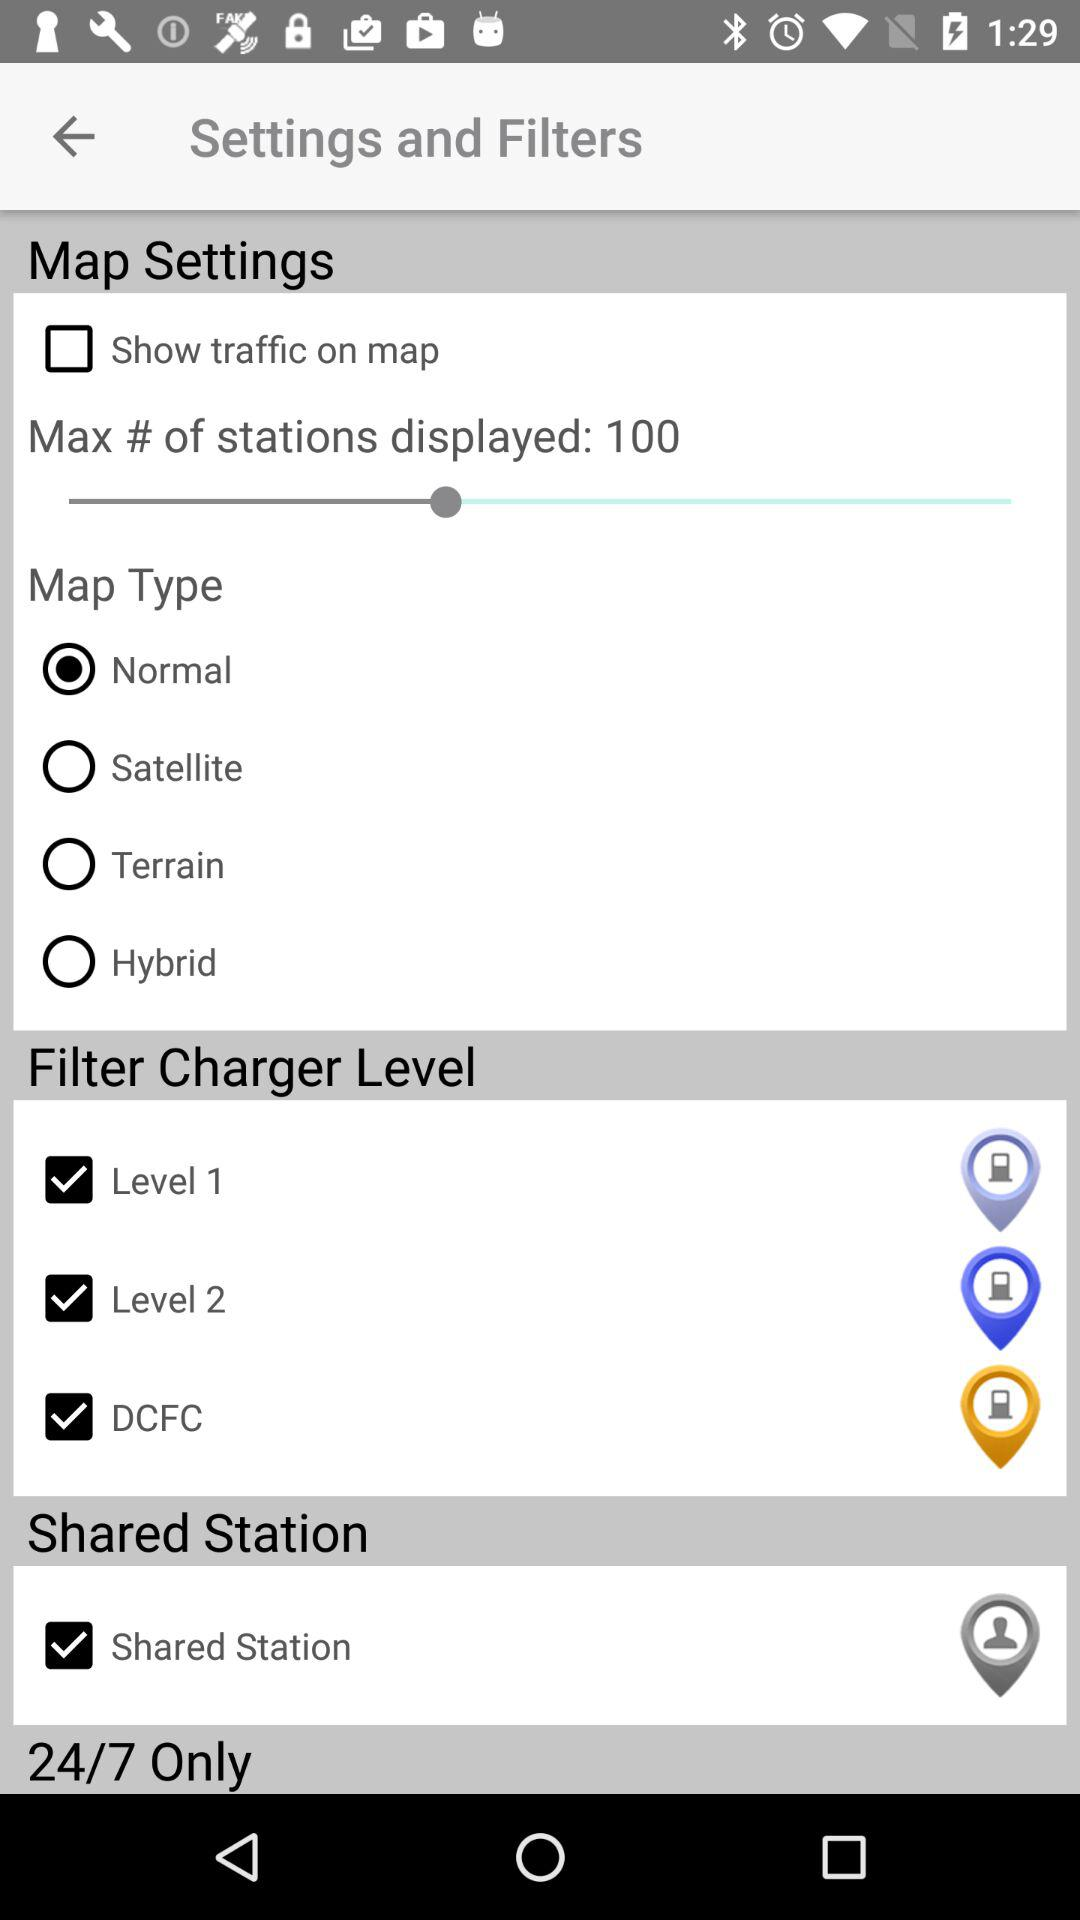What is the selected map type? The selected map type is "Normal". 